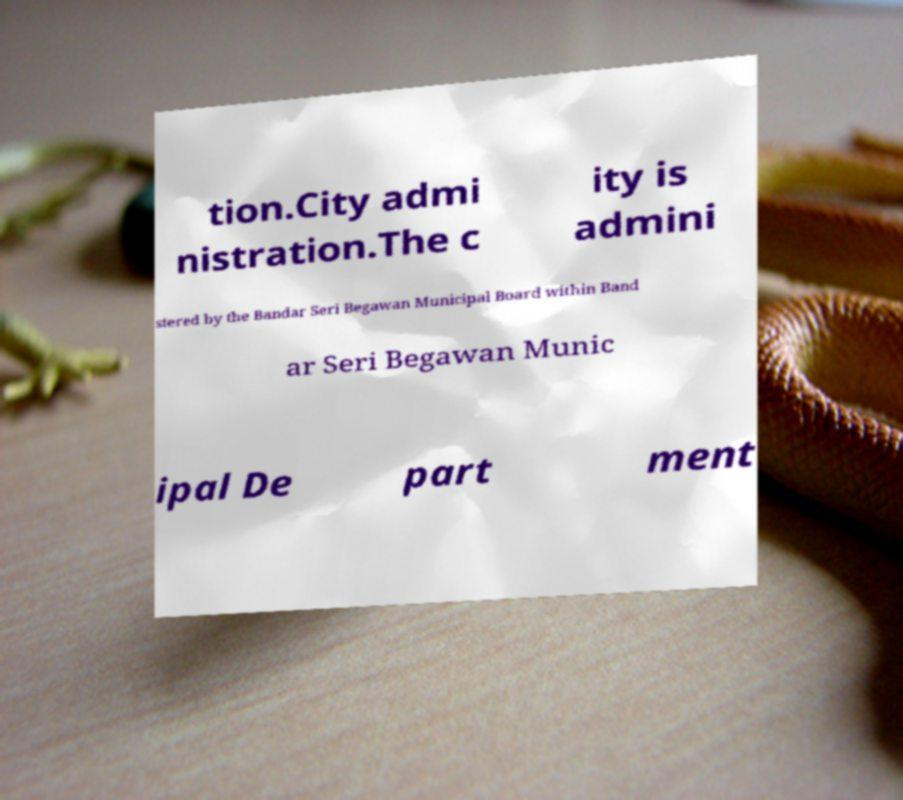There's text embedded in this image that I need extracted. Can you transcribe it verbatim? tion.City admi nistration.The c ity is admini stered by the Bandar Seri Begawan Municipal Board within Band ar Seri Begawan Munic ipal De part ment 